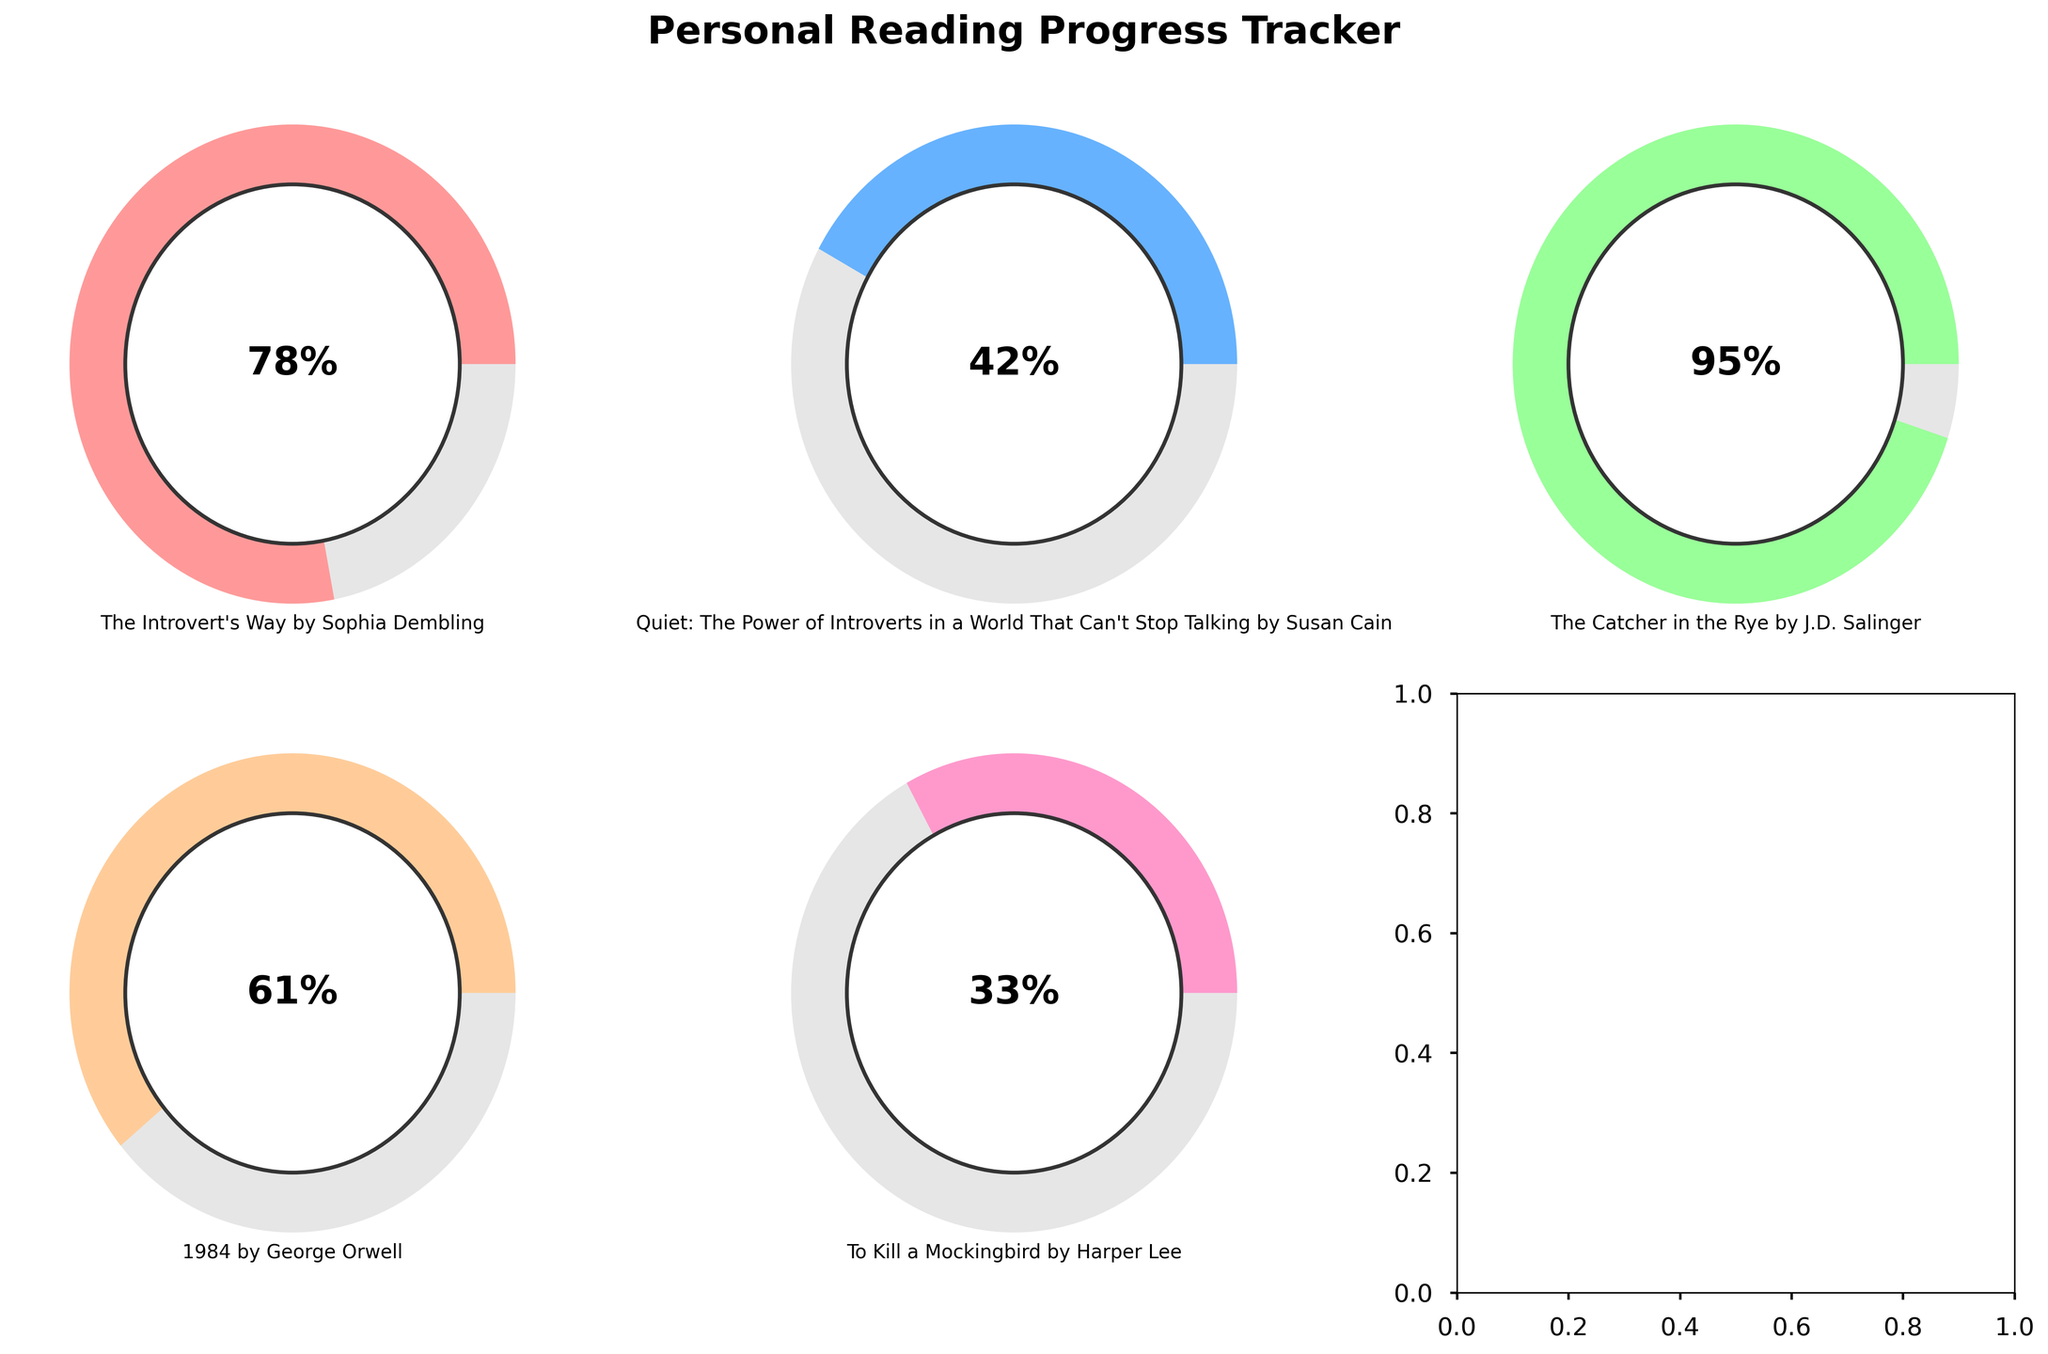What's the highest percentage of any book completed? The highest percentage is represented by the segment that reaches the furthest around the gauge. By comparing all the gauges, the book with the highest percentage completed is "The Catcher in the Rye" by J.D. Salinger at 95%.
Answer: 95% What's the average percentage completed for all the books? To find the average percentage, sum the percentages of all books and divide by the number of books. The sum is 78 + 42 + 95 + 61 + 33 = 309. There are 5 books. So, the average percentage is 309 / 5 = 61.8%.
Answer: 61.8% Which book is the least completed? The gauge with the smallest percentage completion indicates the least completed book. "To Kill a Mockingbird" by Harper Lee has the smallest percentage at 33%.
Answer: "To Kill a Mockingbird" by Harper Lee What is the difference in percentage completed between "Quiet: The Power of Introverts" and "1984"? Calculate the absolute difference between the two percentages. "Quiet: The Power of Introverts" is 42%, and "1984" is 61%. The difference is 61 - 42 = 19%.
Answer: 19% How many books have a completion percentage greater than 50%? By observing the gauges, the books with completion percentages greater than 50% are "The Introvert's Way", "The Catcher in the Rye", and "1984". This makes a total of 3 books.
Answer: 3 Which book is halfway completed? Checking for the gauge where the percentage is closest to 50%, none of the percentages is exactly 50%, but "Quiet: The Power of Introverts" by Susan Cain is 42%, which is the closest to halfway.
Answer: "Quiet: The Power of Introverts" by Susan Cain What color is used to represent "The Catcher in the Rye"? By observing the colors associated with each gauge and title, "The Catcher in the Rye" uses a light green color (though exact color names can vary).
Answer: Light green Which two books have the closest percentage completion? Comparing the percentages, "1984" (61%) and "The Introvert's Way" (78%) have the smallest difference (17%).
Answer: "1984" and "The Introvert’s Way" What percentage of "1984" has been completed? The gauge representing "1984" shows a completion percentage of 61%.
Answer: 61% What's the sum of the percentages completed for "The Introvert's Way" and "Quiet: The Power of Introverts"? Sum the two percentages: 78% (The Introvert's Way) + 42% (Quiet: The Power of Introverts) = 120%.
Answer: 120% 